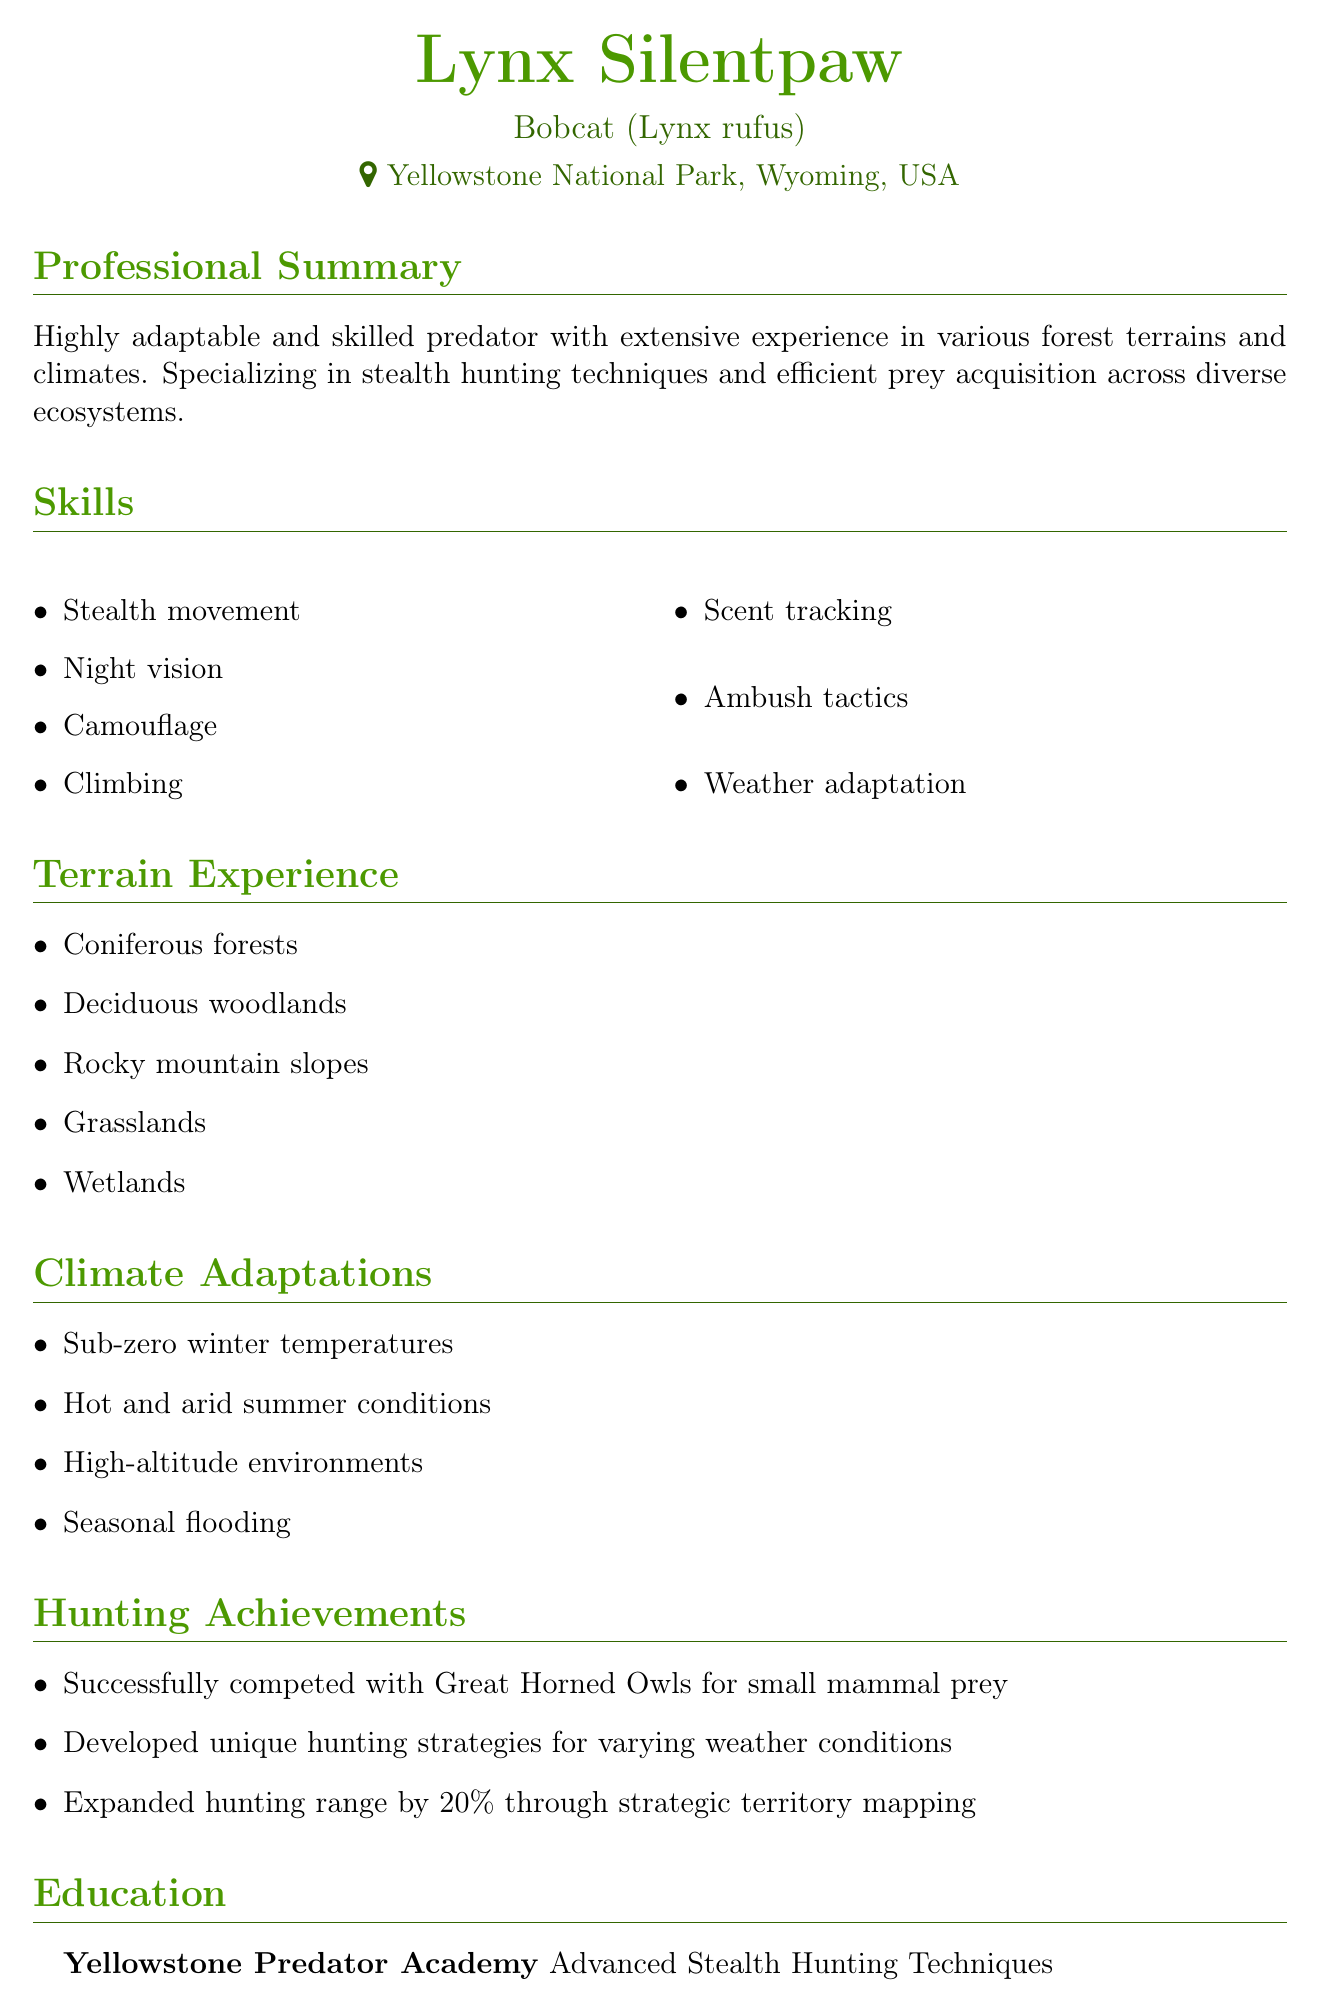What is the name of the individual? The individual's name is prominently displayed at the top of the document.
Answer: Lynx Silentpaw What species does the individual belong to? The species information is found just below the name.
Answer: Bobcat (Lynx rufus) Where is the individual located? The location is indicated beneath the species section.
Answer: Yellowstone National Park, Wyoming, USA What is one of the skills listed? The skills section highlights various capabilities.
Answer: Stealth movement How many types of terrains does the individual have experience in? The terrain experience section lists specific terrain types.
Answer: Five What recognition did the individual achieve concerning hunting range expansion? The achievements section notes key hunting accomplishments related to territory.
Answer: 20% Which academy did the individual attend? The education section specifies the institution attended.
Answer: Yellowstone Predator Academy What is the certification received by the individual? The education section also includes the type of certification.
Answer: Advanced Stealth Hunting Techniques How many professional affiliations are listed? The professional affiliations section counts the listed memberships and contributions.
Answer: Two 